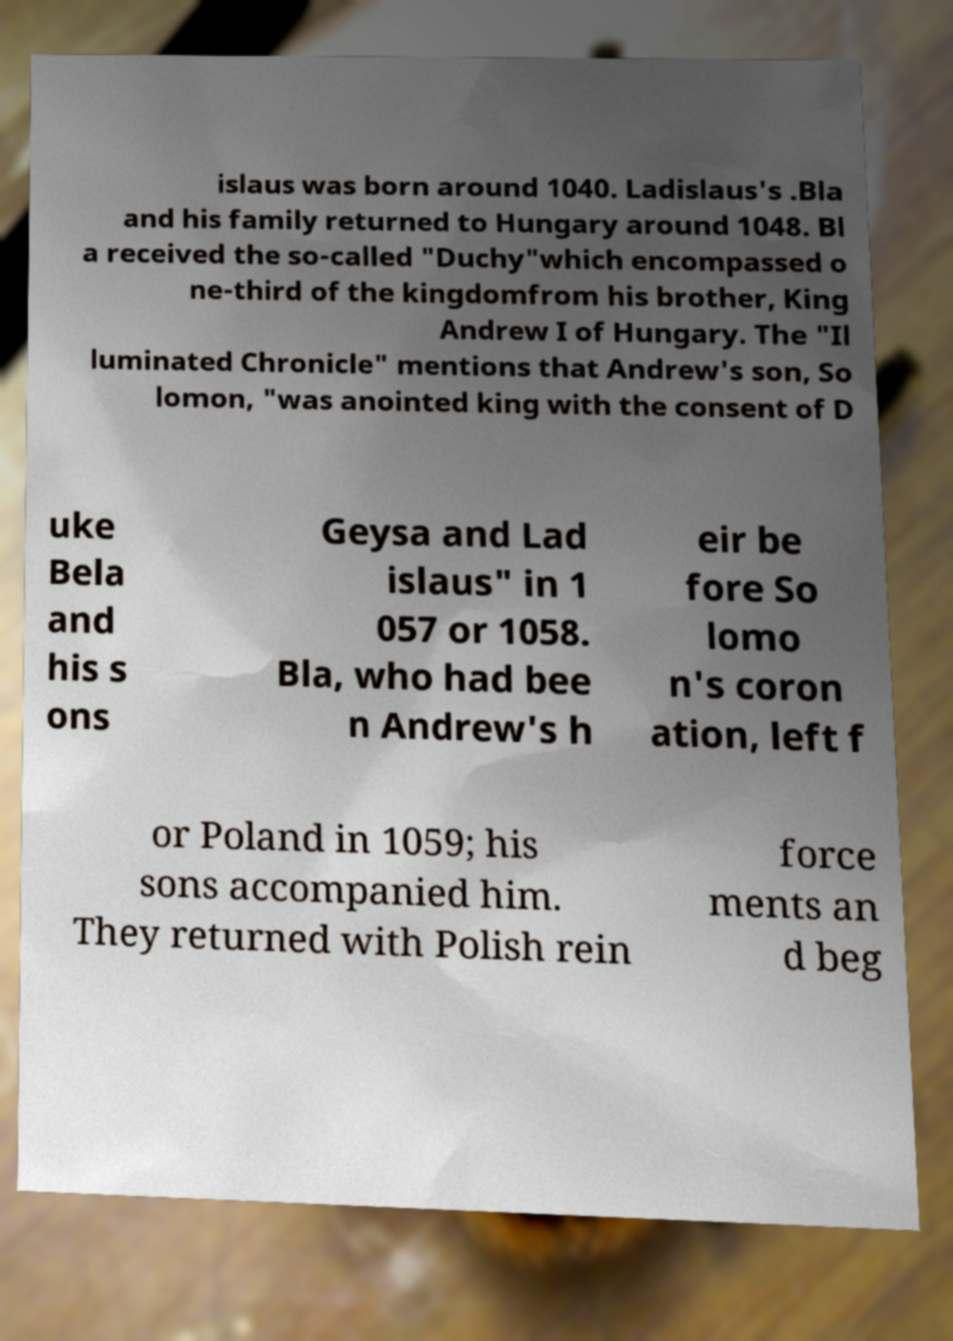Can you read and provide the text displayed in the image?This photo seems to have some interesting text. Can you extract and type it out for me? islaus was born around 1040. Ladislaus's .Bla and his family returned to Hungary around 1048. Bl a received the so-called "Duchy"which encompassed o ne-third of the kingdomfrom his brother, King Andrew I of Hungary. The "Il luminated Chronicle" mentions that Andrew's son, So lomon, "was anointed king with the consent of D uke Bela and his s ons Geysa and Lad islaus" in 1 057 or 1058. Bla, who had bee n Andrew's h eir be fore So lomo n's coron ation, left f or Poland in 1059; his sons accompanied him. They returned with Polish rein force ments an d beg 